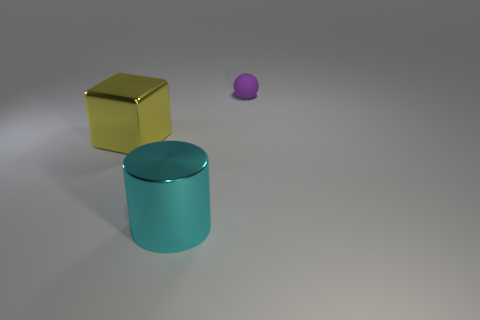Add 3 big red shiny balls. How many objects exist? 6 Subtract all cubes. How many objects are left? 2 Add 2 big yellow metal things. How many big yellow metal things are left? 3 Add 2 objects. How many objects exist? 5 Subtract 0 blue cubes. How many objects are left? 3 Subtract all big yellow cubes. Subtract all big objects. How many objects are left? 0 